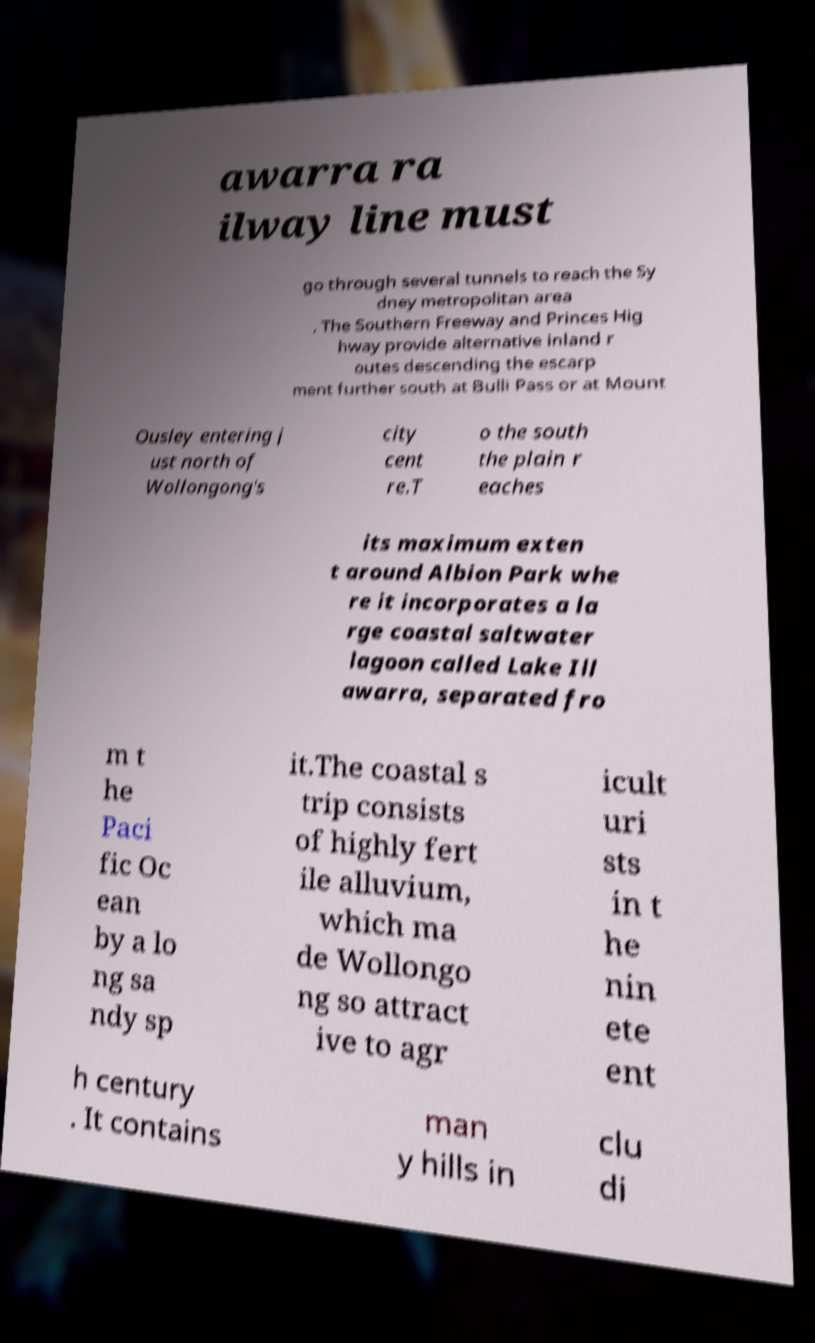There's text embedded in this image that I need extracted. Can you transcribe it verbatim? awarra ra ilway line must go through several tunnels to reach the Sy dney metropolitan area . The Southern Freeway and Princes Hig hway provide alternative inland r outes descending the escarp ment further south at Bulli Pass or at Mount Ousley entering j ust north of Wollongong's city cent re.T o the south the plain r eaches its maximum exten t around Albion Park whe re it incorporates a la rge coastal saltwater lagoon called Lake Ill awarra, separated fro m t he Paci fic Oc ean by a lo ng sa ndy sp it.The coastal s trip consists of highly fert ile alluvium, which ma de Wollongo ng so attract ive to agr icult uri sts in t he nin ete ent h century . It contains man y hills in clu di 